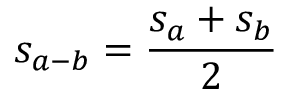Convert formula to latex. <formula><loc_0><loc_0><loc_500><loc_500>s _ { a - b } = \frac { s _ { a } + s _ { b } } { 2 }</formula> 